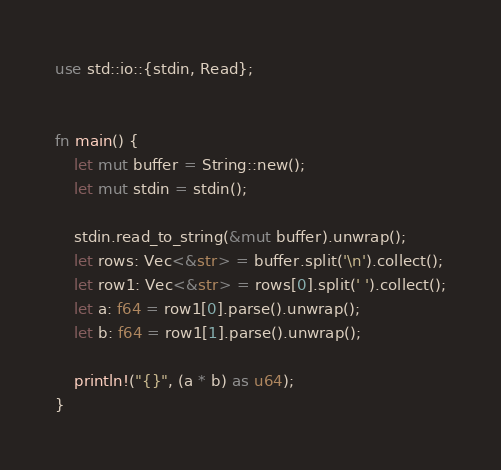Convert code to text. <code><loc_0><loc_0><loc_500><loc_500><_Rust_>use std::io::{stdin, Read};


fn main() {
    let mut buffer = String::new();
    let mut stdin = stdin();

    stdin.read_to_string(&mut buffer).unwrap();
    let rows: Vec<&str> = buffer.split('\n').collect();
    let row1: Vec<&str> = rows[0].split(' ').collect();
    let a: f64 = row1[0].parse().unwrap();
    let b: f64 = row1[1].parse().unwrap();

    println!("{}", (a * b) as u64);
}
</code> 